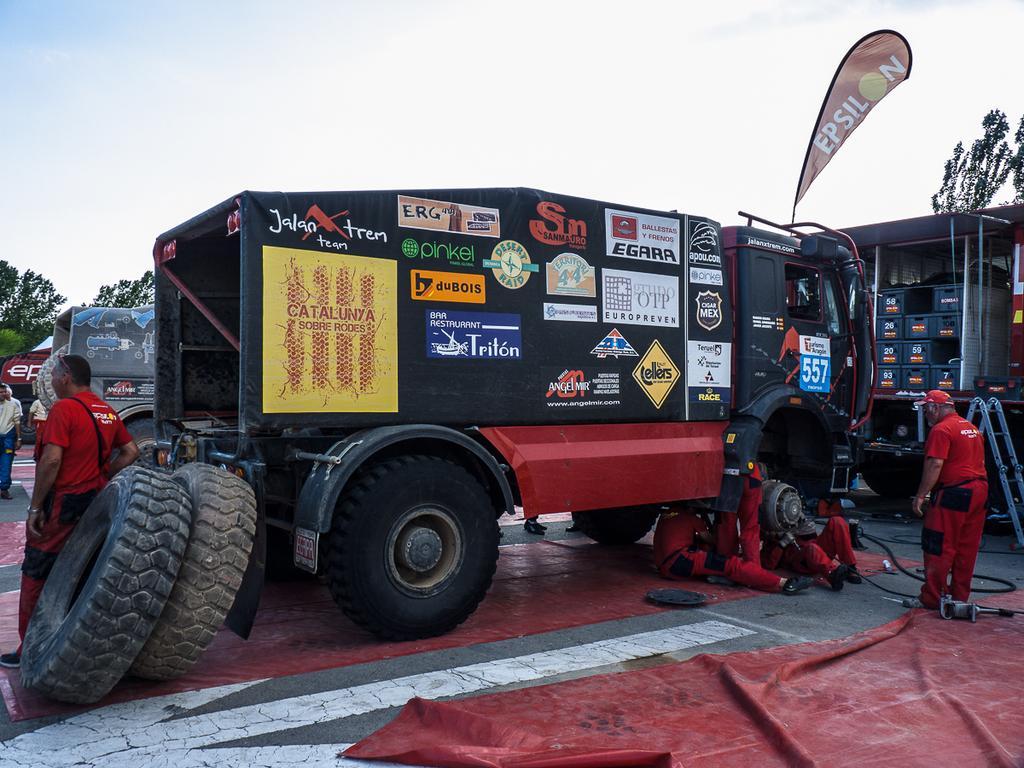Can you describe this image briefly? This is an outside view. Here I can see few vehicles on the ground. There are few people wearing red color dresses and repairing the vehicle. On the left side there are two wheels and a man is standing. In the background there are some trees. On the top of the image I can see the sky. 